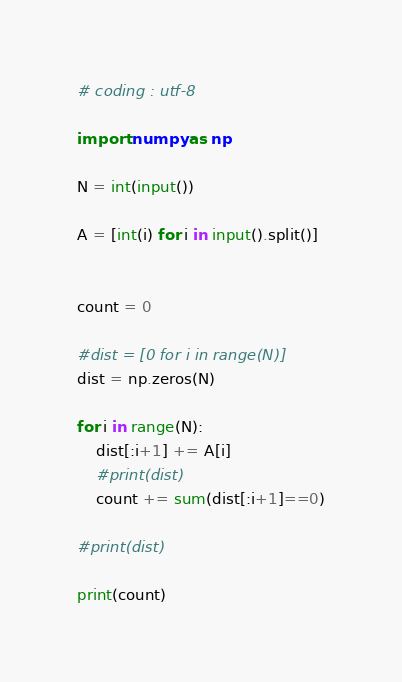Convert code to text. <code><loc_0><loc_0><loc_500><loc_500><_Python_># coding : utf-8
 
import numpy as np
 
N = int(input())
 
A = [int(i) for i in input().split()]
 
 
count = 0
 
#dist = [0 for i in range(N)]
dist = np.zeros(N)
 
for i in range(N):
	dist[:i+1] += A[i]
	#print(dist)
	count += sum(dist[:i+1]==0)
 
#print(dist)
 
print(count)</code> 